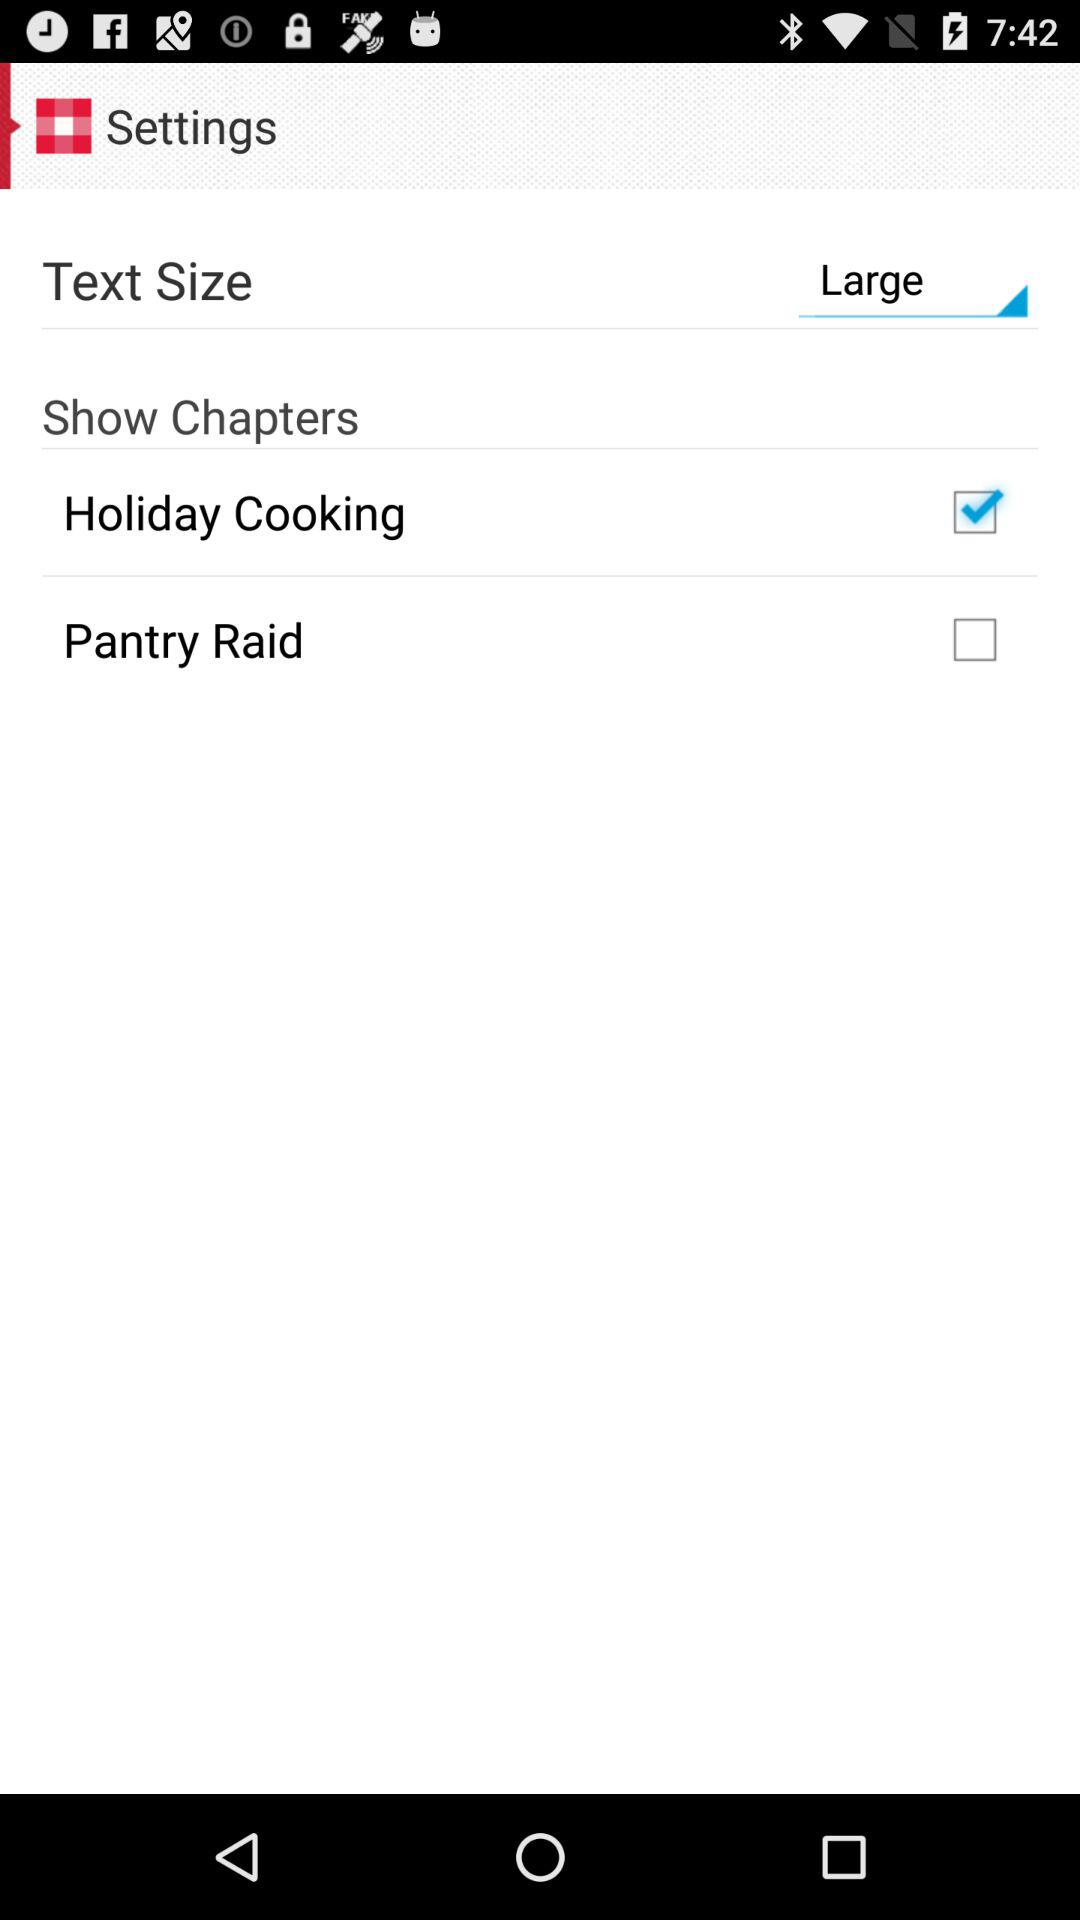Which option is checked in "Show Chapters"? The checked option is "Holiday Cooking". 